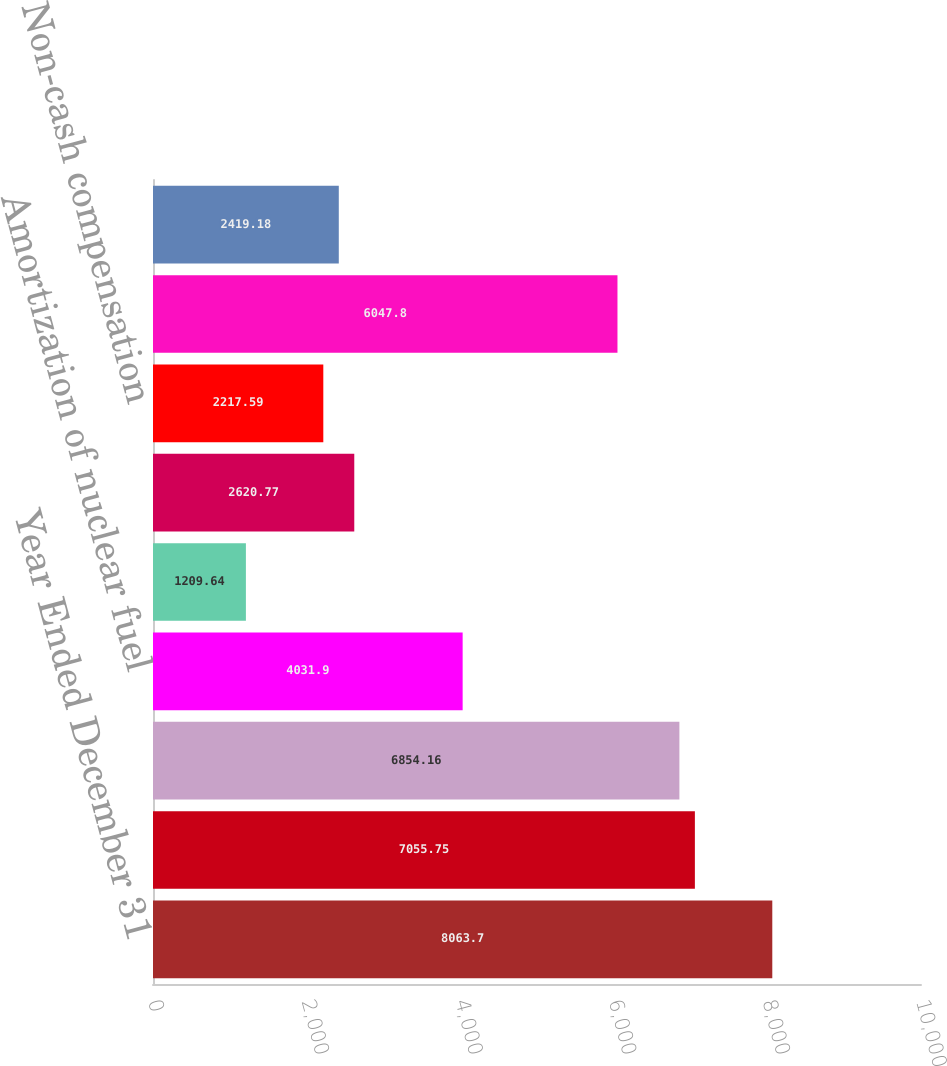Convert chart to OTSL. <chart><loc_0><loc_0><loc_500><loc_500><bar_chart><fcel>Year Ended December 31<fcel>Net income<fcel>Depreciation and amortization<fcel>Amortization of nuclear fuel<fcel>Amortization of deferred<fcel>Amortization of<fcel>Non-cash compensation<fcel>Net deferred income taxes and<fcel>Allowance for equity funds<nl><fcel>8063.7<fcel>7055.75<fcel>6854.16<fcel>4031.9<fcel>1209.64<fcel>2620.77<fcel>2217.59<fcel>6047.8<fcel>2419.18<nl></chart> 